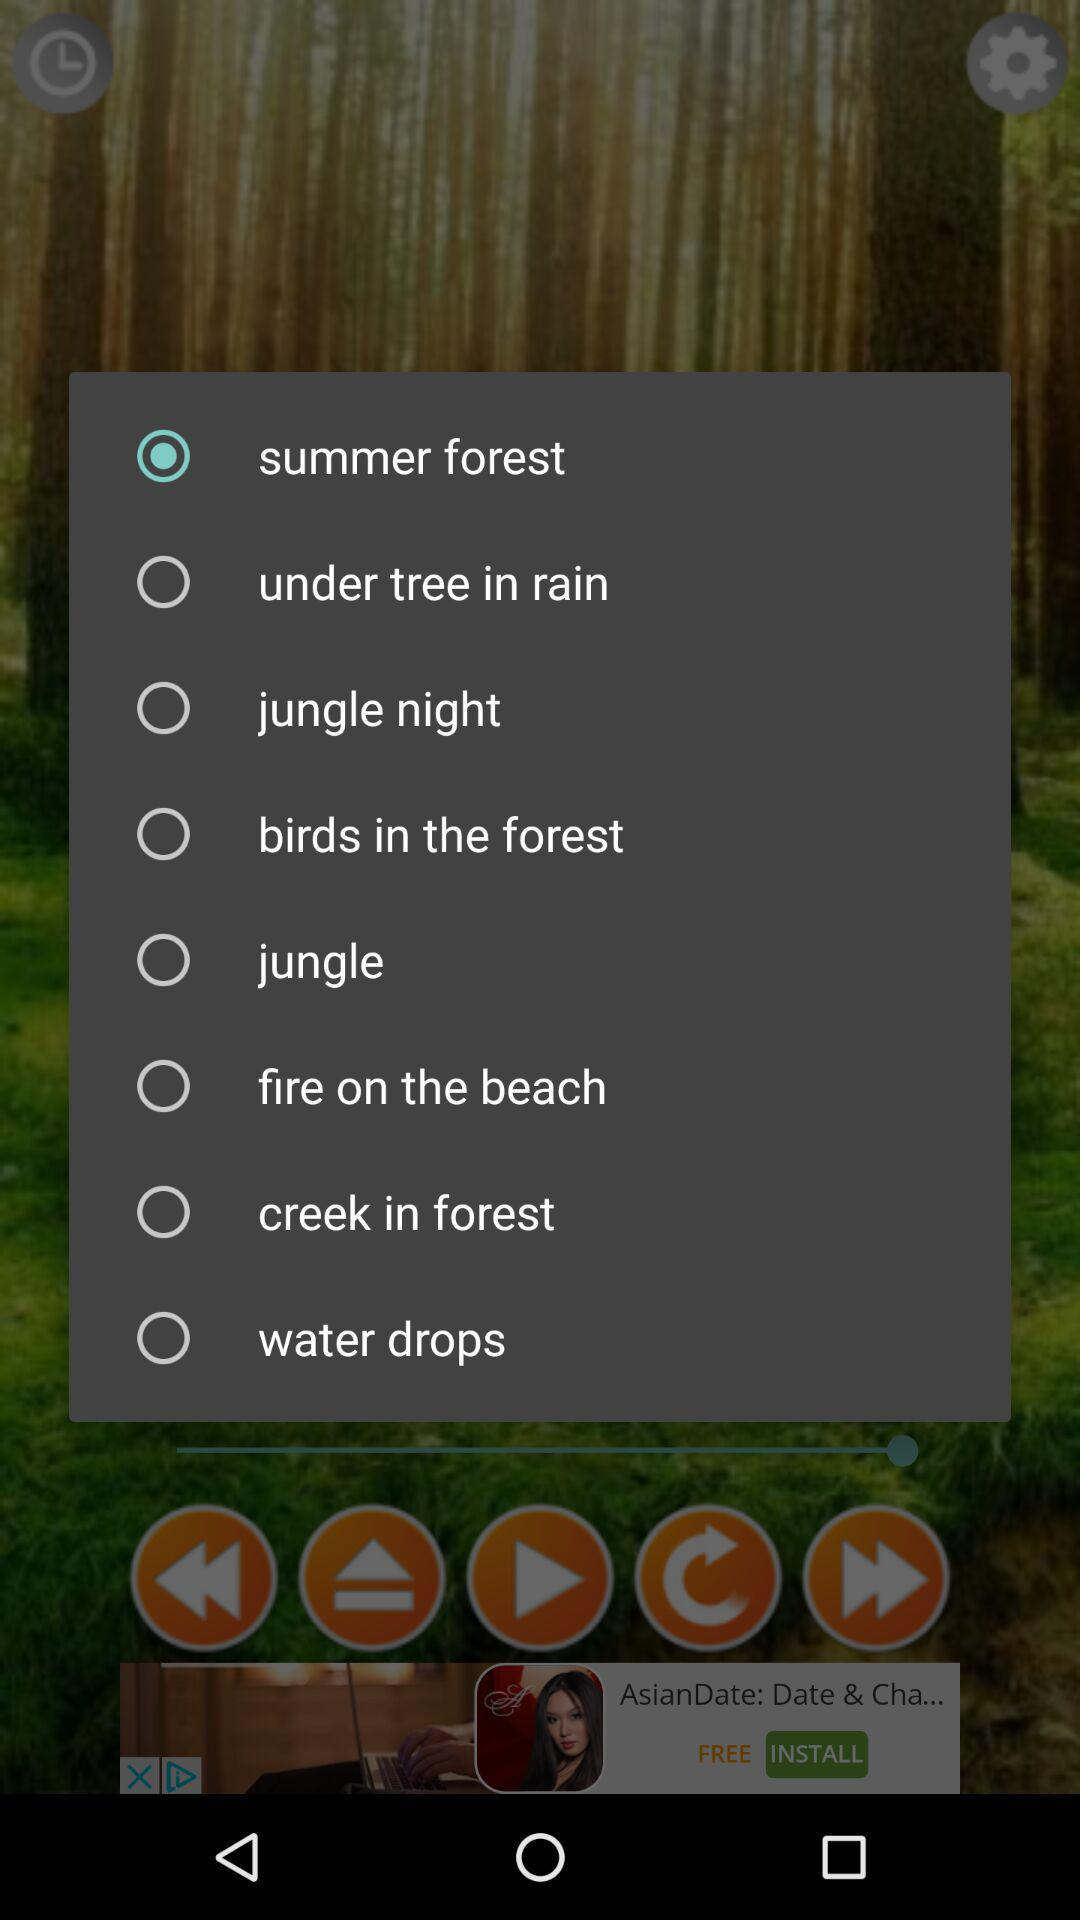What is the selected sound? The selected sound is "summer forest". 